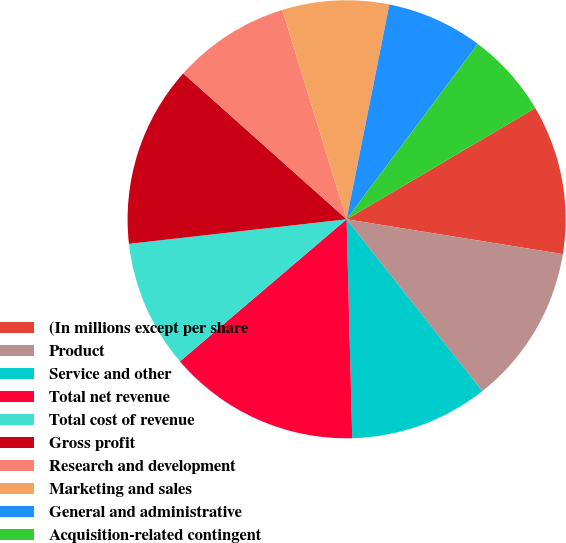<chart> <loc_0><loc_0><loc_500><loc_500><pie_chart><fcel>(In millions except per share<fcel>Product<fcel>Service and other<fcel>Total net revenue<fcel>Total cost of revenue<fcel>Gross profit<fcel>Research and development<fcel>Marketing and sales<fcel>General and administrative<fcel>Acquisition-related contingent<nl><fcel>11.02%<fcel>11.81%<fcel>10.24%<fcel>14.17%<fcel>9.45%<fcel>13.39%<fcel>8.66%<fcel>7.87%<fcel>7.09%<fcel>6.3%<nl></chart> 